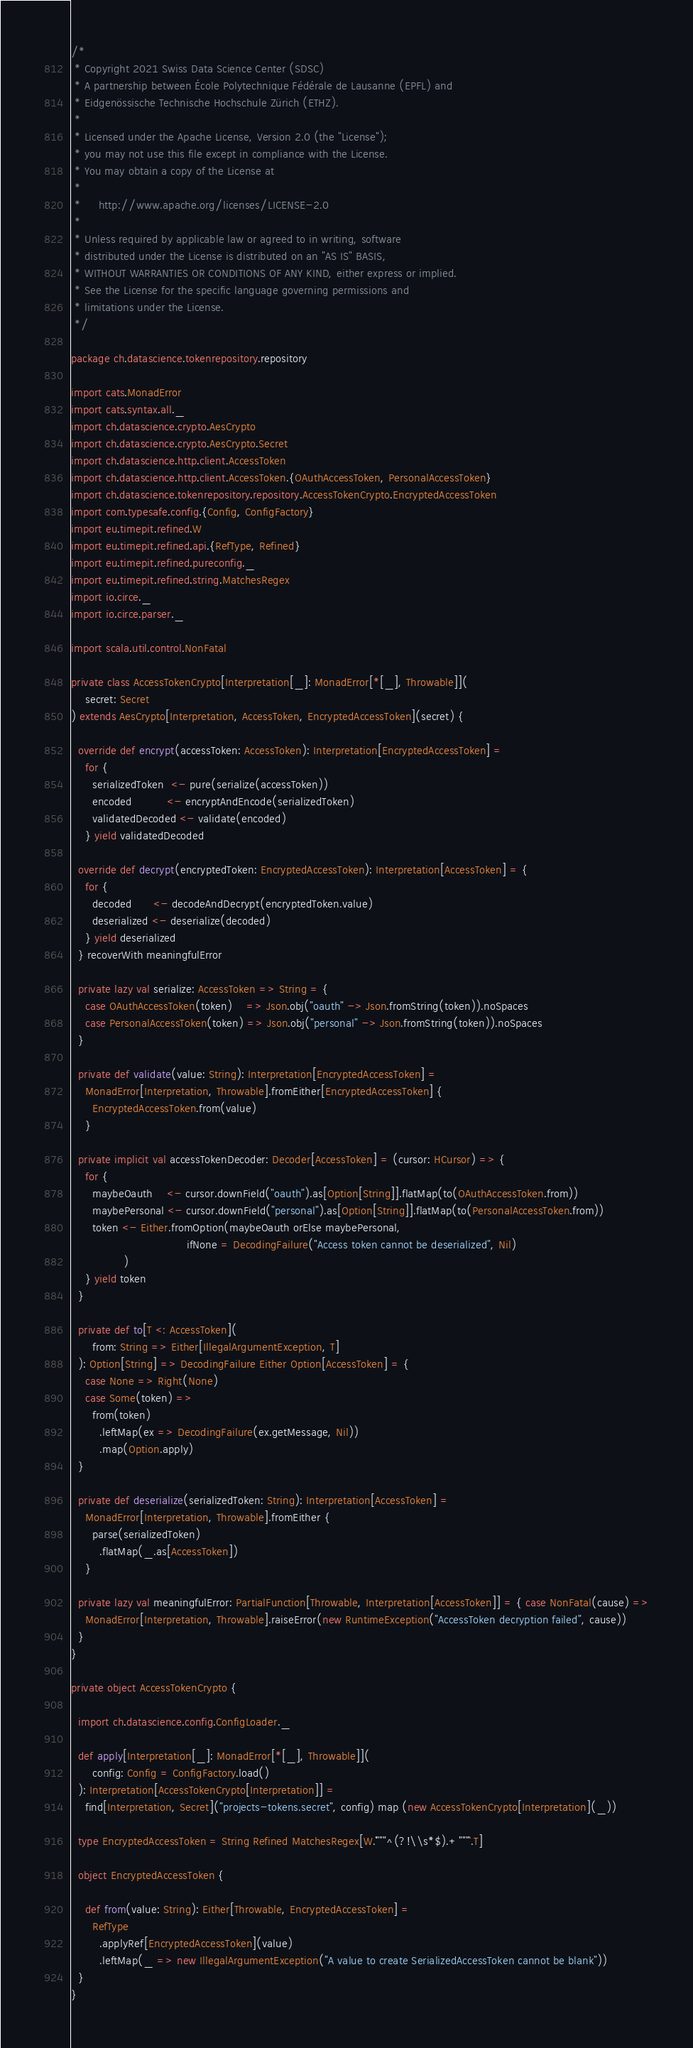<code> <loc_0><loc_0><loc_500><loc_500><_Scala_>/*
 * Copyright 2021 Swiss Data Science Center (SDSC)
 * A partnership between École Polytechnique Fédérale de Lausanne (EPFL) and
 * Eidgenössische Technische Hochschule Zürich (ETHZ).
 *
 * Licensed under the Apache License, Version 2.0 (the "License");
 * you may not use this file except in compliance with the License.
 * You may obtain a copy of the License at
 *
 *     http://www.apache.org/licenses/LICENSE-2.0
 *
 * Unless required by applicable law or agreed to in writing, software
 * distributed under the License is distributed on an "AS IS" BASIS,
 * WITHOUT WARRANTIES OR CONDITIONS OF ANY KIND, either express or implied.
 * See the License for the specific language governing permissions and
 * limitations under the License.
 */

package ch.datascience.tokenrepository.repository

import cats.MonadError
import cats.syntax.all._
import ch.datascience.crypto.AesCrypto
import ch.datascience.crypto.AesCrypto.Secret
import ch.datascience.http.client.AccessToken
import ch.datascience.http.client.AccessToken.{OAuthAccessToken, PersonalAccessToken}
import ch.datascience.tokenrepository.repository.AccessTokenCrypto.EncryptedAccessToken
import com.typesafe.config.{Config, ConfigFactory}
import eu.timepit.refined.W
import eu.timepit.refined.api.{RefType, Refined}
import eu.timepit.refined.pureconfig._
import eu.timepit.refined.string.MatchesRegex
import io.circe._
import io.circe.parser._

import scala.util.control.NonFatal

private class AccessTokenCrypto[Interpretation[_]: MonadError[*[_], Throwable]](
    secret: Secret
) extends AesCrypto[Interpretation, AccessToken, EncryptedAccessToken](secret) {

  override def encrypt(accessToken: AccessToken): Interpretation[EncryptedAccessToken] =
    for {
      serializedToken  <- pure(serialize(accessToken))
      encoded          <- encryptAndEncode(serializedToken)
      validatedDecoded <- validate(encoded)
    } yield validatedDecoded

  override def decrypt(encryptedToken: EncryptedAccessToken): Interpretation[AccessToken] = {
    for {
      decoded      <- decodeAndDecrypt(encryptedToken.value)
      deserialized <- deserialize(decoded)
    } yield deserialized
  } recoverWith meaningfulError

  private lazy val serialize: AccessToken => String = {
    case OAuthAccessToken(token)    => Json.obj("oauth" -> Json.fromString(token)).noSpaces
    case PersonalAccessToken(token) => Json.obj("personal" -> Json.fromString(token)).noSpaces
  }

  private def validate(value: String): Interpretation[EncryptedAccessToken] =
    MonadError[Interpretation, Throwable].fromEither[EncryptedAccessToken] {
      EncryptedAccessToken.from(value)
    }

  private implicit val accessTokenDecoder: Decoder[AccessToken] = (cursor: HCursor) => {
    for {
      maybeOauth    <- cursor.downField("oauth").as[Option[String]].flatMap(to(OAuthAccessToken.from))
      maybePersonal <- cursor.downField("personal").as[Option[String]].flatMap(to(PersonalAccessToken.from))
      token <- Either.fromOption(maybeOauth orElse maybePersonal,
                                 ifNone = DecodingFailure("Access token cannot be deserialized", Nil)
               )
    } yield token
  }

  private def to[T <: AccessToken](
      from: String => Either[IllegalArgumentException, T]
  ): Option[String] => DecodingFailure Either Option[AccessToken] = {
    case None => Right(None)
    case Some(token) =>
      from(token)
        .leftMap(ex => DecodingFailure(ex.getMessage, Nil))
        .map(Option.apply)
  }

  private def deserialize(serializedToken: String): Interpretation[AccessToken] =
    MonadError[Interpretation, Throwable].fromEither {
      parse(serializedToken)
        .flatMap(_.as[AccessToken])
    }

  private lazy val meaningfulError: PartialFunction[Throwable, Interpretation[AccessToken]] = { case NonFatal(cause) =>
    MonadError[Interpretation, Throwable].raiseError(new RuntimeException("AccessToken decryption failed", cause))
  }
}

private object AccessTokenCrypto {

  import ch.datascience.config.ConfigLoader._

  def apply[Interpretation[_]: MonadError[*[_], Throwable]](
      config: Config = ConfigFactory.load()
  ): Interpretation[AccessTokenCrypto[Interpretation]] =
    find[Interpretation, Secret]("projects-tokens.secret", config) map (new AccessTokenCrypto[Interpretation](_))

  type EncryptedAccessToken = String Refined MatchesRegex[W.`"""^(?!\\s*$).+"""`.T]

  object EncryptedAccessToken {

    def from(value: String): Either[Throwable, EncryptedAccessToken] =
      RefType
        .applyRef[EncryptedAccessToken](value)
        .leftMap(_ => new IllegalArgumentException("A value to create SerializedAccessToken cannot be blank"))
  }
}
</code> 